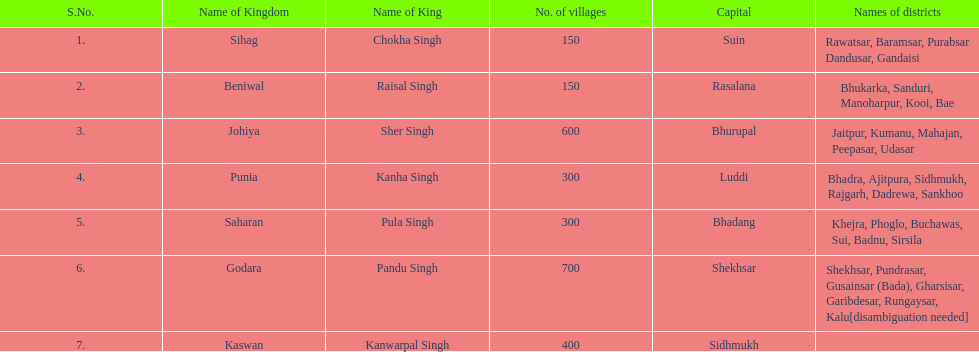What is the next kingdom listed after sihag? Beniwal. 